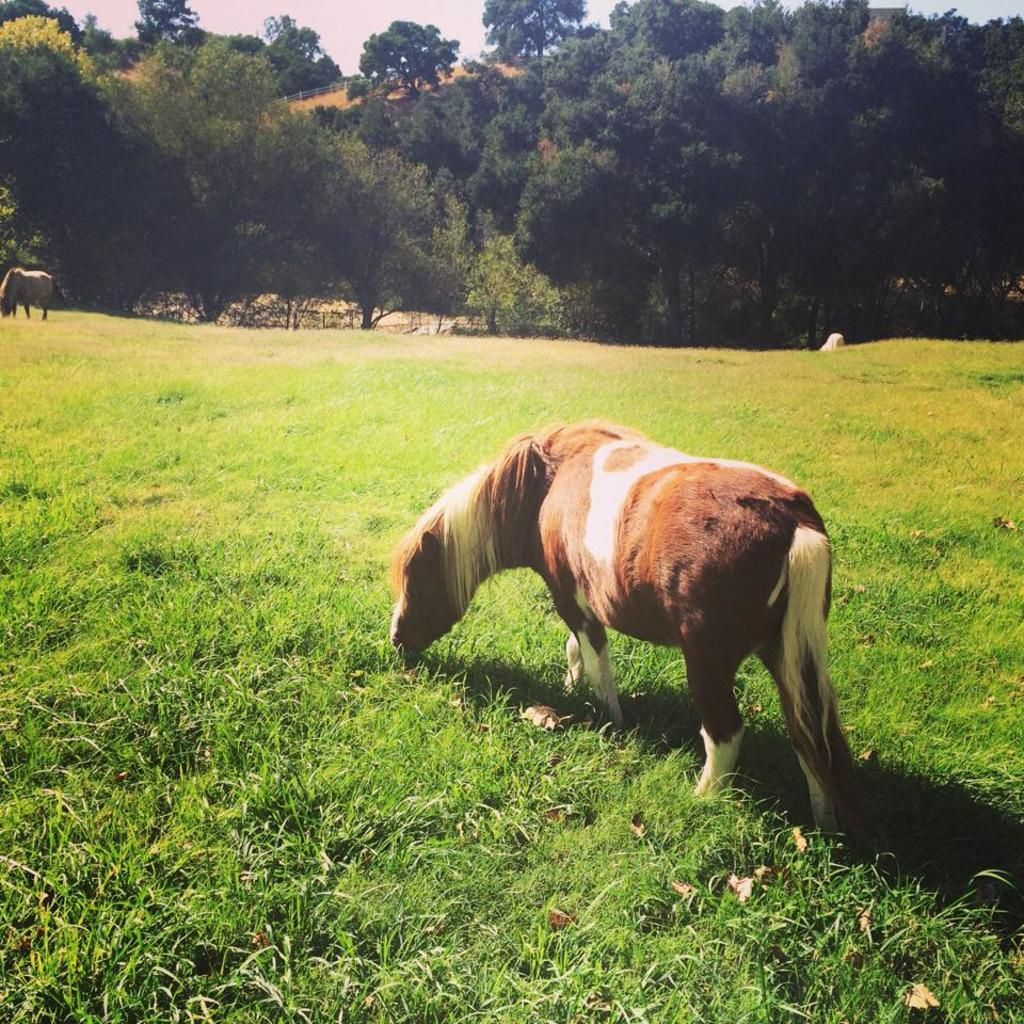What is the main subject of the image? There is a horse grazing the grass in the image. Can you describe the setting of the image? There is another horse in the distance, and there are many trees in the background of the image. What type of joke is the horse telling in the image? There is no indication in the image that the horse is telling a joke, as horses do not have the ability to communicate verbally. 